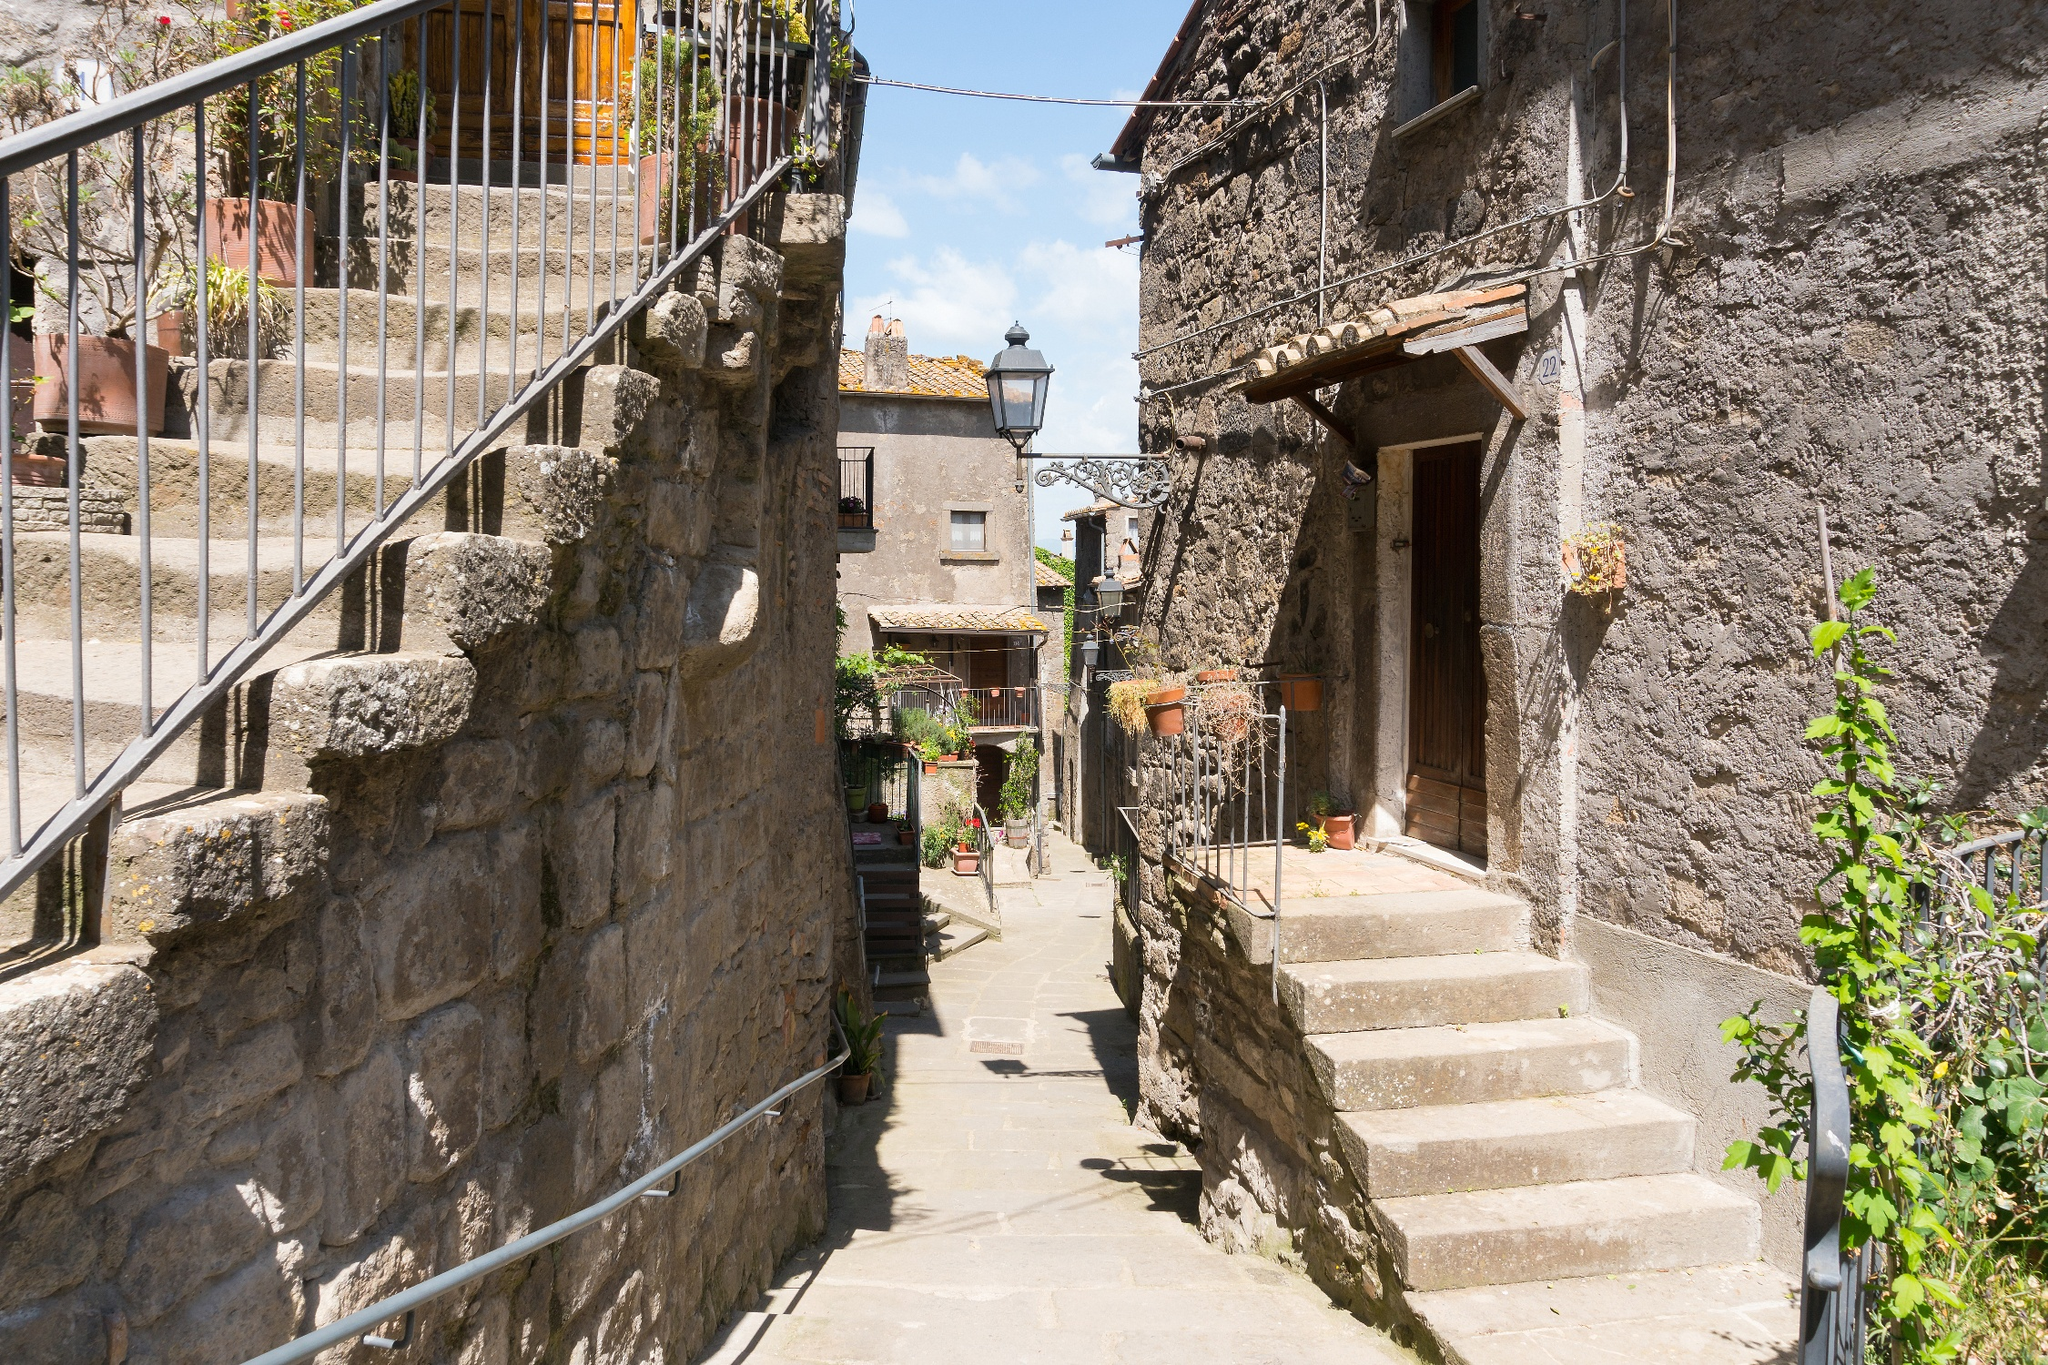Imagine this village during a festive celebration. What would it look like? During a festive celebration, this village transforms into a vibrant tapestry of joy and color. The cobblestone alleyways are adorned with strings of twinkling lights and colorful banners fluttering in the breeze. Doors and windows are decorated with garlands of fresh flowers, and the air is filled with the sound of laughter and music. Stalls line the streets, offering an array of delicious local foods and handcrafted goods. The courtyard with its fountain becomes the center of festivities, where musicians play lively tunes and dancers twirl in traditional attire. The entire village comes alive with the spirit of celebration, as friends and families gather, sharing stories and creating memories. The night sky is illuminated with fireworks, marking the culmination of the festivities and casting a magical glow over the entire scene, making it a night to remember. 